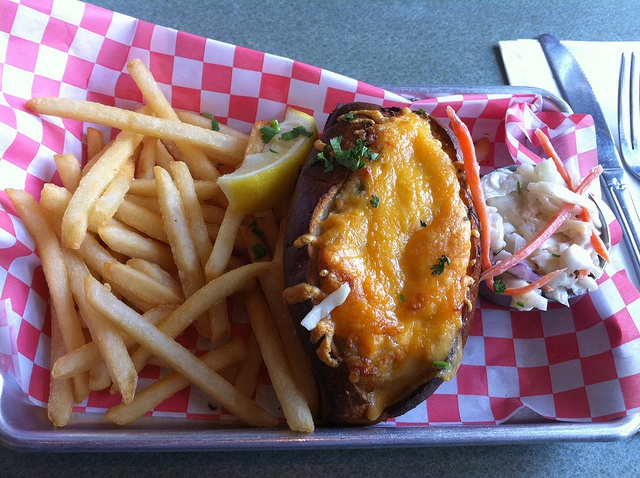Describe the objects in this image and their specific colors. I can see dining table in black, white, maroon, gray, and brown tones, sandwich in violet, black, brown, maroon, and orange tones, knife in violet, gray, white, and lightblue tones, and fork in violet, white, lightblue, and gray tones in this image. 